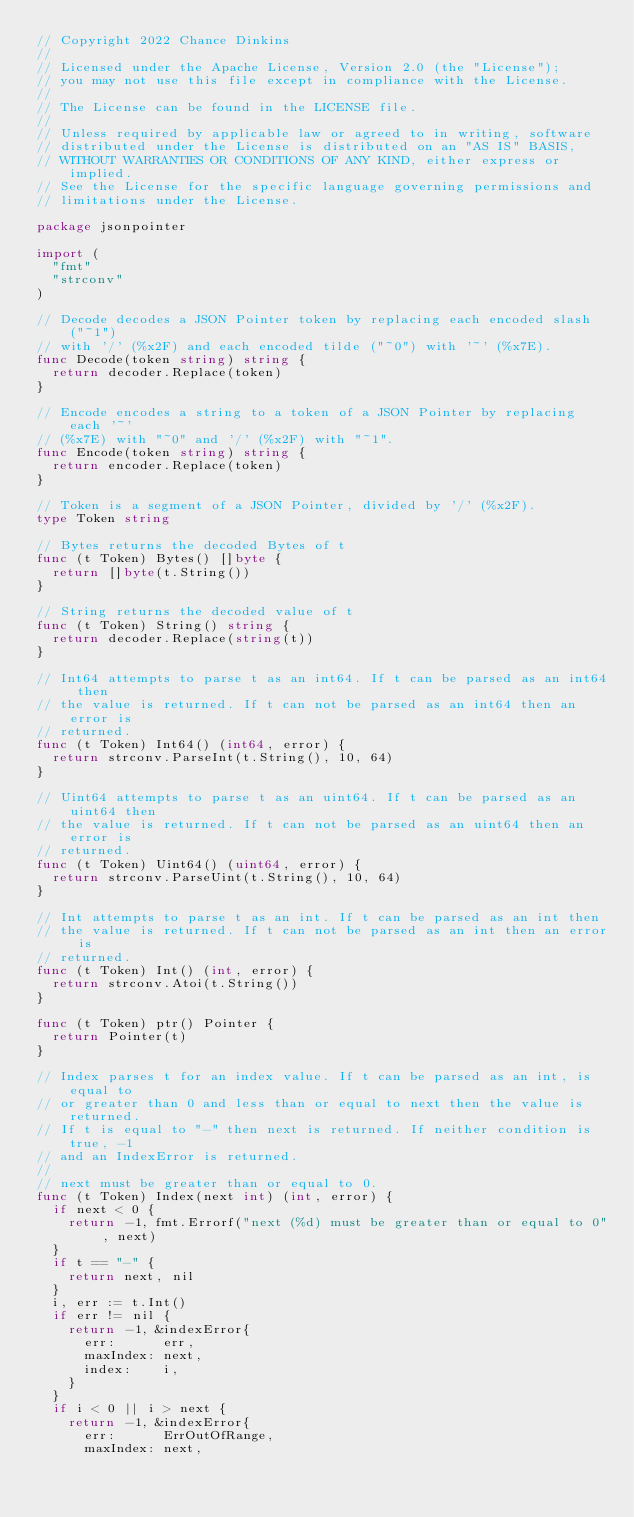<code> <loc_0><loc_0><loc_500><loc_500><_Go_>// Copyright 2022 Chance Dinkins
//
// Licensed under the Apache License, Version 2.0 (the "License");
// you may not use this file except in compliance with the License.
//
// The License can be found in the LICENSE file.
//
// Unless required by applicable law or agreed to in writing, software
// distributed under the License is distributed on an "AS IS" BASIS,
// WITHOUT WARRANTIES OR CONDITIONS OF ANY KIND, either express or implied.
// See the License for the specific language governing permissions and
// limitations under the License.

package jsonpointer

import (
	"fmt"
	"strconv"
)

// Decode decodes a JSON Pointer token by replacing each encoded slash ("~1")
// with '/' (%x2F) and each encoded tilde ("~0") with '~' (%x7E).
func Decode(token string) string {
	return decoder.Replace(token)
}

// Encode encodes a string to a token of a JSON Pointer by replacing each '~'
// (%x7E) with "~0" and '/' (%x2F) with "~1".
func Encode(token string) string {
	return encoder.Replace(token)
}

// Token is a segment of a JSON Pointer, divided by '/' (%x2F).
type Token string

// Bytes returns the decoded Bytes of t
func (t Token) Bytes() []byte {
	return []byte(t.String())
}

// String returns the decoded value of t
func (t Token) String() string {
	return decoder.Replace(string(t))
}

// Int64 attempts to parse t as an int64. If t can be parsed as an int64 then
// the value is returned. If t can not be parsed as an int64 then an error is
// returned.
func (t Token) Int64() (int64, error) {
	return strconv.ParseInt(t.String(), 10, 64)
}

// Uint64 attempts to parse t as an uint64. If t can be parsed as an uint64 then
// the value is returned. If t can not be parsed as an uint64 then an error is
// returned.
func (t Token) Uint64() (uint64, error) {
	return strconv.ParseUint(t.String(), 10, 64)
}

// Int attempts to parse t as an int. If t can be parsed as an int then
// the value is returned. If t can not be parsed as an int then an error is
// returned.
func (t Token) Int() (int, error) {
	return strconv.Atoi(t.String())
}

func (t Token) ptr() Pointer {
	return Pointer(t)
}

// Index parses t for an index value. If t can be parsed as an int, is equal to
// or greater than 0 and less than or equal to next then the value is returned.
// If t is equal to "-" then next is returned. If neither condition is true, -1
// and an IndexError is returned.
//
// next must be greater than or equal to 0.
func (t Token) Index(next int) (int, error) {
	if next < 0 {
		return -1, fmt.Errorf("next (%d) must be greater than or equal to 0", next)
	}
	if t == "-" {
		return next, nil
	}
	i, err := t.Int()
	if err != nil {
		return -1, &indexError{
			err:      err,
			maxIndex: next,
			index:    i,
		}
	}
	if i < 0 || i > next {
		return -1, &indexError{
			err:      ErrOutOfRange,
			maxIndex: next,</code> 